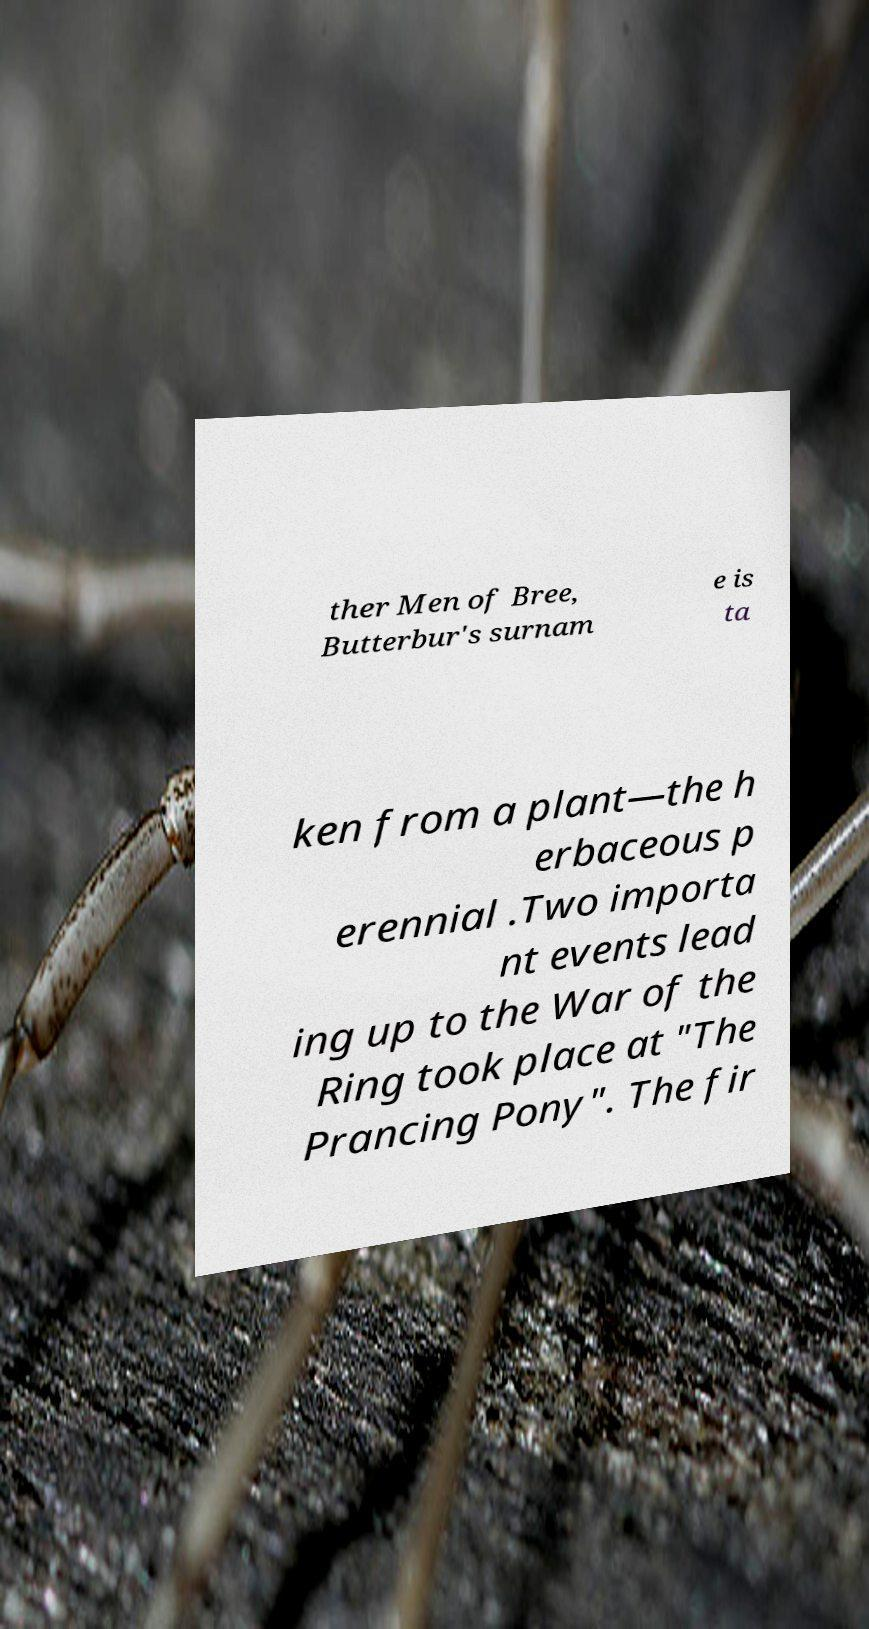Could you extract and type out the text from this image? ther Men of Bree, Butterbur's surnam e is ta ken from a plant—the h erbaceous p erennial .Two importa nt events lead ing up to the War of the Ring took place at "The Prancing Pony". The fir 